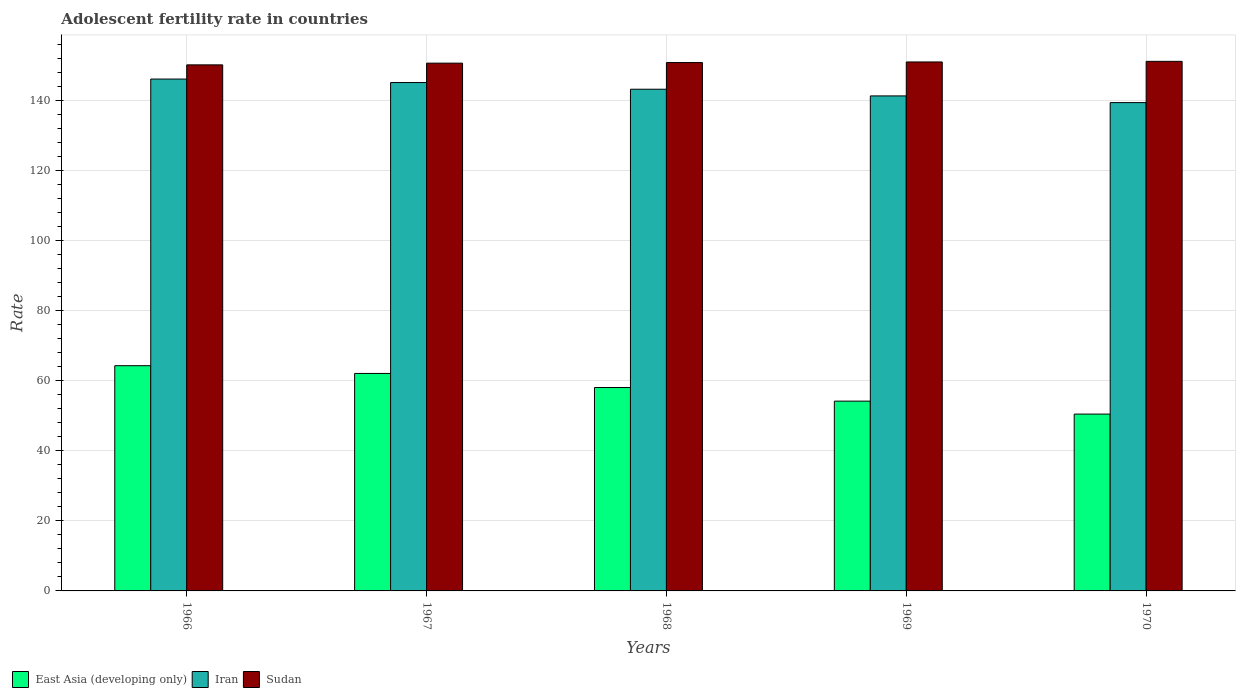How many different coloured bars are there?
Provide a short and direct response. 3. How many groups of bars are there?
Keep it short and to the point. 5. Are the number of bars per tick equal to the number of legend labels?
Ensure brevity in your answer.  Yes. Are the number of bars on each tick of the X-axis equal?
Your answer should be compact. Yes. How many bars are there on the 3rd tick from the right?
Offer a terse response. 3. What is the label of the 3rd group of bars from the left?
Keep it short and to the point. 1968. In how many cases, is the number of bars for a given year not equal to the number of legend labels?
Ensure brevity in your answer.  0. What is the adolescent fertility rate in Sudan in 1967?
Offer a very short reply. 150.75. Across all years, what is the maximum adolescent fertility rate in Iran?
Keep it short and to the point. 146.21. Across all years, what is the minimum adolescent fertility rate in East Asia (developing only)?
Make the answer very short. 50.51. In which year was the adolescent fertility rate in Iran maximum?
Ensure brevity in your answer.  1966. What is the total adolescent fertility rate in Sudan in the graph?
Make the answer very short. 754.29. What is the difference between the adolescent fertility rate in Sudan in 1968 and that in 1970?
Keep it short and to the point. -0.34. What is the difference between the adolescent fertility rate in East Asia (developing only) in 1969 and the adolescent fertility rate in Iran in 1967?
Keep it short and to the point. -91. What is the average adolescent fertility rate in Sudan per year?
Your answer should be very brief. 150.86. In the year 1967, what is the difference between the adolescent fertility rate in East Asia (developing only) and adolescent fertility rate in Sudan?
Make the answer very short. -88.63. What is the ratio of the adolescent fertility rate in East Asia (developing only) in 1966 to that in 1967?
Your response must be concise. 1.04. Is the adolescent fertility rate in Sudan in 1968 less than that in 1969?
Your answer should be very brief. Yes. Is the difference between the adolescent fertility rate in East Asia (developing only) in 1967 and 1969 greater than the difference between the adolescent fertility rate in Sudan in 1967 and 1969?
Keep it short and to the point. Yes. What is the difference between the highest and the second highest adolescent fertility rate in East Asia (developing only)?
Provide a succinct answer. 2.21. What is the difference between the highest and the lowest adolescent fertility rate in Iran?
Make the answer very short. 6.73. Is the sum of the adolescent fertility rate in Sudan in 1969 and 1970 greater than the maximum adolescent fertility rate in Iran across all years?
Offer a terse response. Yes. What does the 1st bar from the left in 1967 represents?
Your answer should be very brief. East Asia (developing only). What does the 2nd bar from the right in 1967 represents?
Offer a very short reply. Iran. Is it the case that in every year, the sum of the adolescent fertility rate in Sudan and adolescent fertility rate in East Asia (developing only) is greater than the adolescent fertility rate in Iran?
Your answer should be compact. Yes. Are all the bars in the graph horizontal?
Provide a short and direct response. No. How many years are there in the graph?
Give a very brief answer. 5. What is the difference between two consecutive major ticks on the Y-axis?
Your answer should be very brief. 20. Are the values on the major ticks of Y-axis written in scientific E-notation?
Provide a short and direct response. No. Does the graph contain grids?
Make the answer very short. Yes. What is the title of the graph?
Your answer should be compact. Adolescent fertility rate in countries. Does "Czech Republic" appear as one of the legend labels in the graph?
Your response must be concise. No. What is the label or title of the X-axis?
Your response must be concise. Years. What is the label or title of the Y-axis?
Ensure brevity in your answer.  Rate. What is the Rate of East Asia (developing only) in 1966?
Offer a terse response. 64.33. What is the Rate in Iran in 1966?
Offer a terse response. 146.21. What is the Rate in Sudan in 1966?
Your response must be concise. 150.26. What is the Rate in East Asia (developing only) in 1967?
Provide a succinct answer. 62.12. What is the Rate of Iran in 1967?
Offer a very short reply. 145.21. What is the Rate of Sudan in 1967?
Keep it short and to the point. 150.75. What is the Rate in East Asia (developing only) in 1968?
Make the answer very short. 58.1. What is the Rate in Iran in 1968?
Your answer should be compact. 143.3. What is the Rate of Sudan in 1968?
Your response must be concise. 150.92. What is the Rate in East Asia (developing only) in 1969?
Ensure brevity in your answer.  54.21. What is the Rate of Iran in 1969?
Provide a short and direct response. 141.39. What is the Rate in Sudan in 1969?
Offer a terse response. 151.09. What is the Rate of East Asia (developing only) in 1970?
Your response must be concise. 50.51. What is the Rate of Iran in 1970?
Your answer should be compact. 139.48. What is the Rate of Sudan in 1970?
Give a very brief answer. 151.26. Across all years, what is the maximum Rate of East Asia (developing only)?
Offer a terse response. 64.33. Across all years, what is the maximum Rate of Iran?
Your answer should be very brief. 146.21. Across all years, what is the maximum Rate of Sudan?
Offer a terse response. 151.26. Across all years, what is the minimum Rate in East Asia (developing only)?
Your answer should be very brief. 50.51. Across all years, what is the minimum Rate in Iran?
Keep it short and to the point. 139.48. Across all years, what is the minimum Rate of Sudan?
Offer a very short reply. 150.26. What is the total Rate of East Asia (developing only) in the graph?
Offer a very short reply. 289.27. What is the total Rate in Iran in the graph?
Ensure brevity in your answer.  715.6. What is the total Rate in Sudan in the graph?
Your answer should be very brief. 754.29. What is the difference between the Rate in East Asia (developing only) in 1966 and that in 1967?
Offer a terse response. 2.21. What is the difference between the Rate of Iran in 1966 and that in 1967?
Keep it short and to the point. 0.99. What is the difference between the Rate in Sudan in 1966 and that in 1967?
Provide a short and direct response. -0.49. What is the difference between the Rate in East Asia (developing only) in 1966 and that in 1968?
Offer a very short reply. 6.23. What is the difference between the Rate in Iran in 1966 and that in 1968?
Your answer should be compact. 2.9. What is the difference between the Rate of Sudan in 1966 and that in 1968?
Your answer should be compact. -0.66. What is the difference between the Rate of East Asia (developing only) in 1966 and that in 1969?
Your response must be concise. 10.12. What is the difference between the Rate of Iran in 1966 and that in 1969?
Provide a succinct answer. 4.81. What is the difference between the Rate in Sudan in 1966 and that in 1969?
Ensure brevity in your answer.  -0.83. What is the difference between the Rate of East Asia (developing only) in 1966 and that in 1970?
Ensure brevity in your answer.  13.82. What is the difference between the Rate in Iran in 1966 and that in 1970?
Offer a very short reply. 6.73. What is the difference between the Rate in Sudan in 1966 and that in 1970?
Keep it short and to the point. -1. What is the difference between the Rate in East Asia (developing only) in 1967 and that in 1968?
Give a very brief answer. 4.02. What is the difference between the Rate of Iran in 1967 and that in 1968?
Offer a terse response. 1.91. What is the difference between the Rate in Sudan in 1967 and that in 1968?
Make the answer very short. -0.17. What is the difference between the Rate in East Asia (developing only) in 1967 and that in 1969?
Provide a short and direct response. 7.91. What is the difference between the Rate in Iran in 1967 and that in 1969?
Offer a very short reply. 3.82. What is the difference between the Rate in Sudan in 1967 and that in 1969?
Your response must be concise. -0.34. What is the difference between the Rate in East Asia (developing only) in 1967 and that in 1970?
Offer a very short reply. 11.61. What is the difference between the Rate in Iran in 1967 and that in 1970?
Keep it short and to the point. 5.73. What is the difference between the Rate of Sudan in 1967 and that in 1970?
Your answer should be very brief. -0.51. What is the difference between the Rate in East Asia (developing only) in 1968 and that in 1969?
Provide a succinct answer. 3.89. What is the difference between the Rate of Iran in 1968 and that in 1969?
Provide a succinct answer. 1.91. What is the difference between the Rate in Sudan in 1968 and that in 1969?
Your answer should be compact. -0.17. What is the difference between the Rate of East Asia (developing only) in 1968 and that in 1970?
Ensure brevity in your answer.  7.59. What is the difference between the Rate in Iran in 1968 and that in 1970?
Offer a very short reply. 3.82. What is the difference between the Rate of Sudan in 1968 and that in 1970?
Your response must be concise. -0.34. What is the difference between the Rate of East Asia (developing only) in 1969 and that in 1970?
Provide a succinct answer. 3.7. What is the difference between the Rate of Iran in 1969 and that in 1970?
Offer a terse response. 1.91. What is the difference between the Rate in Sudan in 1969 and that in 1970?
Give a very brief answer. -0.17. What is the difference between the Rate in East Asia (developing only) in 1966 and the Rate in Iran in 1967?
Your answer should be very brief. -80.88. What is the difference between the Rate in East Asia (developing only) in 1966 and the Rate in Sudan in 1967?
Provide a short and direct response. -86.42. What is the difference between the Rate of Iran in 1966 and the Rate of Sudan in 1967?
Offer a terse response. -4.54. What is the difference between the Rate in East Asia (developing only) in 1966 and the Rate in Iran in 1968?
Offer a terse response. -78.97. What is the difference between the Rate in East Asia (developing only) in 1966 and the Rate in Sudan in 1968?
Provide a short and direct response. -86.59. What is the difference between the Rate of Iran in 1966 and the Rate of Sudan in 1968?
Offer a terse response. -4.71. What is the difference between the Rate in East Asia (developing only) in 1966 and the Rate in Iran in 1969?
Your answer should be very brief. -77.06. What is the difference between the Rate in East Asia (developing only) in 1966 and the Rate in Sudan in 1969?
Offer a terse response. -86.76. What is the difference between the Rate in Iran in 1966 and the Rate in Sudan in 1969?
Ensure brevity in your answer.  -4.89. What is the difference between the Rate in East Asia (developing only) in 1966 and the Rate in Iran in 1970?
Provide a short and direct response. -75.15. What is the difference between the Rate of East Asia (developing only) in 1966 and the Rate of Sudan in 1970?
Make the answer very short. -86.93. What is the difference between the Rate of Iran in 1966 and the Rate of Sudan in 1970?
Your answer should be compact. -5.06. What is the difference between the Rate of East Asia (developing only) in 1967 and the Rate of Iran in 1968?
Provide a succinct answer. -81.18. What is the difference between the Rate of East Asia (developing only) in 1967 and the Rate of Sudan in 1968?
Make the answer very short. -88.8. What is the difference between the Rate in Iran in 1967 and the Rate in Sudan in 1968?
Offer a terse response. -5.71. What is the difference between the Rate of East Asia (developing only) in 1967 and the Rate of Iran in 1969?
Give a very brief answer. -79.27. What is the difference between the Rate in East Asia (developing only) in 1967 and the Rate in Sudan in 1969?
Offer a terse response. -88.97. What is the difference between the Rate in Iran in 1967 and the Rate in Sudan in 1969?
Make the answer very short. -5.88. What is the difference between the Rate of East Asia (developing only) in 1967 and the Rate of Iran in 1970?
Offer a very short reply. -77.36. What is the difference between the Rate of East Asia (developing only) in 1967 and the Rate of Sudan in 1970?
Keep it short and to the point. -89.14. What is the difference between the Rate of Iran in 1967 and the Rate of Sudan in 1970?
Provide a succinct answer. -6.05. What is the difference between the Rate of East Asia (developing only) in 1968 and the Rate of Iran in 1969?
Make the answer very short. -83.29. What is the difference between the Rate of East Asia (developing only) in 1968 and the Rate of Sudan in 1969?
Ensure brevity in your answer.  -92.99. What is the difference between the Rate of Iran in 1968 and the Rate of Sudan in 1969?
Ensure brevity in your answer.  -7.79. What is the difference between the Rate in East Asia (developing only) in 1968 and the Rate in Iran in 1970?
Provide a succinct answer. -81.38. What is the difference between the Rate in East Asia (developing only) in 1968 and the Rate in Sudan in 1970?
Offer a very short reply. -93.16. What is the difference between the Rate of Iran in 1968 and the Rate of Sudan in 1970?
Your answer should be very brief. -7.96. What is the difference between the Rate in East Asia (developing only) in 1969 and the Rate in Iran in 1970?
Your answer should be very brief. -85.27. What is the difference between the Rate of East Asia (developing only) in 1969 and the Rate of Sudan in 1970?
Keep it short and to the point. -97.05. What is the difference between the Rate in Iran in 1969 and the Rate in Sudan in 1970?
Make the answer very short. -9.87. What is the average Rate in East Asia (developing only) per year?
Your answer should be compact. 57.85. What is the average Rate of Iran per year?
Ensure brevity in your answer.  143.12. What is the average Rate in Sudan per year?
Provide a succinct answer. 150.86. In the year 1966, what is the difference between the Rate in East Asia (developing only) and Rate in Iran?
Keep it short and to the point. -81.88. In the year 1966, what is the difference between the Rate of East Asia (developing only) and Rate of Sudan?
Give a very brief answer. -85.93. In the year 1966, what is the difference between the Rate in Iran and Rate in Sudan?
Ensure brevity in your answer.  -4.06. In the year 1967, what is the difference between the Rate in East Asia (developing only) and Rate in Iran?
Give a very brief answer. -83.09. In the year 1967, what is the difference between the Rate of East Asia (developing only) and Rate of Sudan?
Provide a short and direct response. -88.63. In the year 1967, what is the difference between the Rate of Iran and Rate of Sudan?
Offer a terse response. -5.54. In the year 1968, what is the difference between the Rate of East Asia (developing only) and Rate of Iran?
Offer a very short reply. -85.2. In the year 1968, what is the difference between the Rate in East Asia (developing only) and Rate in Sudan?
Your response must be concise. -92.82. In the year 1968, what is the difference between the Rate in Iran and Rate in Sudan?
Provide a succinct answer. -7.62. In the year 1969, what is the difference between the Rate of East Asia (developing only) and Rate of Iran?
Your answer should be very brief. -87.18. In the year 1969, what is the difference between the Rate in East Asia (developing only) and Rate in Sudan?
Offer a terse response. -96.88. In the year 1969, what is the difference between the Rate in Iran and Rate in Sudan?
Offer a very short reply. -9.7. In the year 1970, what is the difference between the Rate in East Asia (developing only) and Rate in Iran?
Provide a short and direct response. -88.97. In the year 1970, what is the difference between the Rate of East Asia (developing only) and Rate of Sudan?
Your answer should be very brief. -100.75. In the year 1970, what is the difference between the Rate of Iran and Rate of Sudan?
Make the answer very short. -11.78. What is the ratio of the Rate of East Asia (developing only) in 1966 to that in 1967?
Your answer should be compact. 1.04. What is the ratio of the Rate of Iran in 1966 to that in 1967?
Ensure brevity in your answer.  1.01. What is the ratio of the Rate in Sudan in 1966 to that in 1967?
Provide a short and direct response. 1. What is the ratio of the Rate of East Asia (developing only) in 1966 to that in 1968?
Provide a succinct answer. 1.11. What is the ratio of the Rate of Iran in 1966 to that in 1968?
Ensure brevity in your answer.  1.02. What is the ratio of the Rate in East Asia (developing only) in 1966 to that in 1969?
Offer a terse response. 1.19. What is the ratio of the Rate in Iran in 1966 to that in 1969?
Keep it short and to the point. 1.03. What is the ratio of the Rate of Sudan in 1966 to that in 1969?
Make the answer very short. 0.99. What is the ratio of the Rate in East Asia (developing only) in 1966 to that in 1970?
Keep it short and to the point. 1.27. What is the ratio of the Rate in Iran in 1966 to that in 1970?
Your answer should be compact. 1.05. What is the ratio of the Rate of East Asia (developing only) in 1967 to that in 1968?
Offer a very short reply. 1.07. What is the ratio of the Rate of Iran in 1967 to that in 1968?
Ensure brevity in your answer.  1.01. What is the ratio of the Rate in East Asia (developing only) in 1967 to that in 1969?
Make the answer very short. 1.15. What is the ratio of the Rate in Sudan in 1967 to that in 1969?
Keep it short and to the point. 1. What is the ratio of the Rate of East Asia (developing only) in 1967 to that in 1970?
Make the answer very short. 1.23. What is the ratio of the Rate of Iran in 1967 to that in 1970?
Ensure brevity in your answer.  1.04. What is the ratio of the Rate of East Asia (developing only) in 1968 to that in 1969?
Ensure brevity in your answer.  1.07. What is the ratio of the Rate of Iran in 1968 to that in 1969?
Provide a short and direct response. 1.01. What is the ratio of the Rate of Sudan in 1968 to that in 1969?
Your answer should be very brief. 1. What is the ratio of the Rate of East Asia (developing only) in 1968 to that in 1970?
Your answer should be compact. 1.15. What is the ratio of the Rate of Iran in 1968 to that in 1970?
Provide a short and direct response. 1.03. What is the ratio of the Rate in East Asia (developing only) in 1969 to that in 1970?
Offer a very short reply. 1.07. What is the ratio of the Rate in Iran in 1969 to that in 1970?
Give a very brief answer. 1.01. What is the difference between the highest and the second highest Rate of East Asia (developing only)?
Give a very brief answer. 2.21. What is the difference between the highest and the second highest Rate of Sudan?
Your response must be concise. 0.17. What is the difference between the highest and the lowest Rate of East Asia (developing only)?
Provide a succinct answer. 13.82. What is the difference between the highest and the lowest Rate of Iran?
Provide a succinct answer. 6.73. 